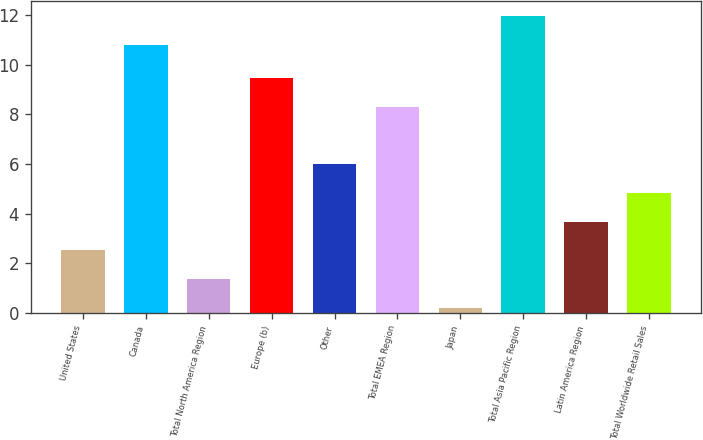Convert chart to OTSL. <chart><loc_0><loc_0><loc_500><loc_500><bar_chart><fcel>United States<fcel>Canada<fcel>Total North America Region<fcel>Europe (b)<fcel>Other<fcel>Total EMEA Region<fcel>Japan<fcel>Total Asia Pacific Region<fcel>Latin America Region<fcel>Total Worldwide Retail Sales<nl><fcel>2.52<fcel>10.8<fcel>1.36<fcel>9.48<fcel>6<fcel>8.32<fcel>0.2<fcel>11.96<fcel>3.68<fcel>4.84<nl></chart> 